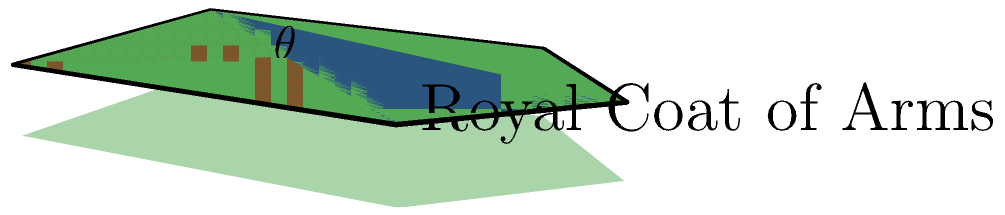In this royal coat of arms shield, two planes intersect to form the upper part. The red plane is defined by points (0,0,0), (2,0,0), and (2,3,0), while the blue plane is defined by points (0,0,0), (2,3,0), and (1,4,0). What is the angle $\theta$ between these two planes? To find the angle between two planes, we need to follow these steps:

1) Find the normal vectors of both planes:
   For plane 1 (red): $\vec{n_1} = (0,0,1) \times (2,3,0) = (-3,2,0)$
   For plane 2 (blue): $\vec{n_2} = (2,3,0) \times (1,4,0) = (-3,-2,2)$

2) The angle between the planes is the same as the angle between their normal vectors. We can find this using the dot product formula:

   $\cos \theta = \frac{\vec{n_1} \cdot \vec{n_2}}{|\vec{n_1}||\vec{n_2}|}$

3) Calculate the dot product:
   $\vec{n_1} \cdot \vec{n_2} = (-3)(-3) + (2)(-2) + (0)(2) = 13$

4) Calculate the magnitudes:
   $|\vec{n_1}| = \sqrt{(-3)^2 + 2^2 + 0^2} = \sqrt{13}$
   $|\vec{n_2}| = \sqrt{(-3)^2 + (-2)^2 + 2^2} = \sqrt{17}$

5) Substitute into the formula:
   $\cos \theta = \frac{13}{\sqrt{13}\sqrt{17}}$

6) Take the inverse cosine (arccos) of both sides:
   $\theta = \arccos(\frac{13}{\sqrt{13}\sqrt{17}})$

7) Calculate the result:
   $\theta \approx 44.42°$
Answer: $44.42°$ 